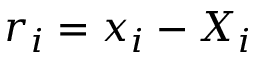<formula> <loc_0><loc_0><loc_500><loc_500>r _ { i } = x _ { i } - X _ { i }</formula> 